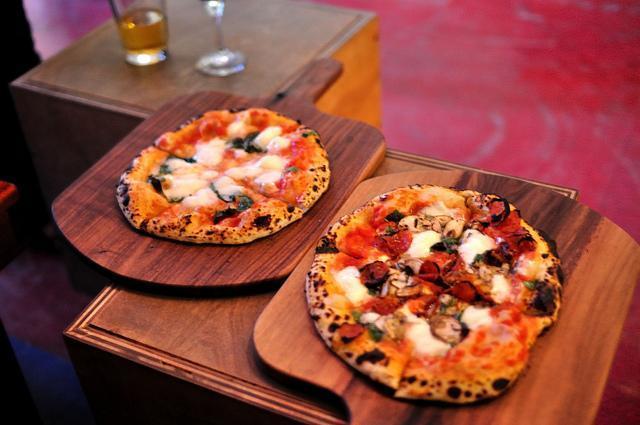How many dining tables are visible?
Give a very brief answer. 2. How many pizzas are there?
Give a very brief answer. 2. 